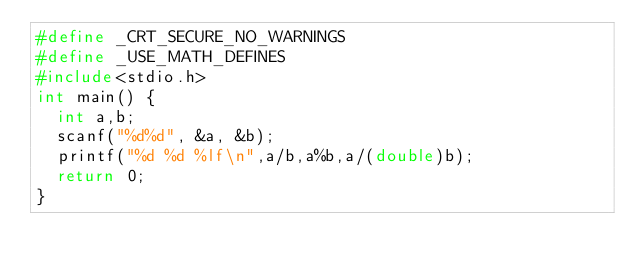Convert code to text. <code><loc_0><loc_0><loc_500><loc_500><_C_>#define _CRT_SECURE_NO_WARNINGS
#define _USE_MATH_DEFINES
#include<stdio.h>
int main() {
	int a,b;
	scanf("%d%d", &a, &b);
	printf("%d %d %lf\n",a/b,a%b,a/(double)b);
	return 0;
}</code> 